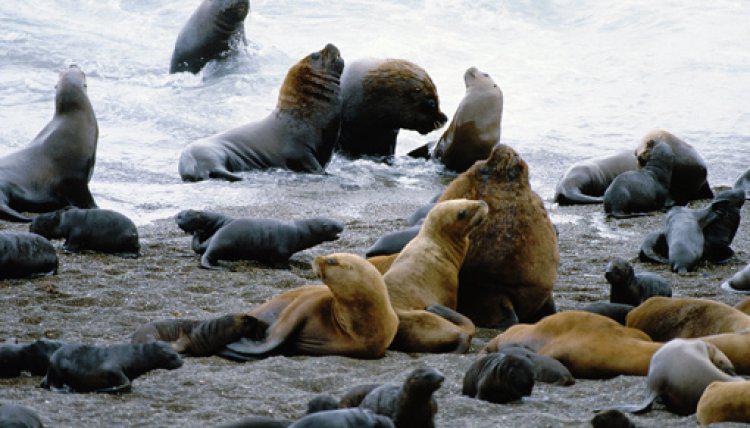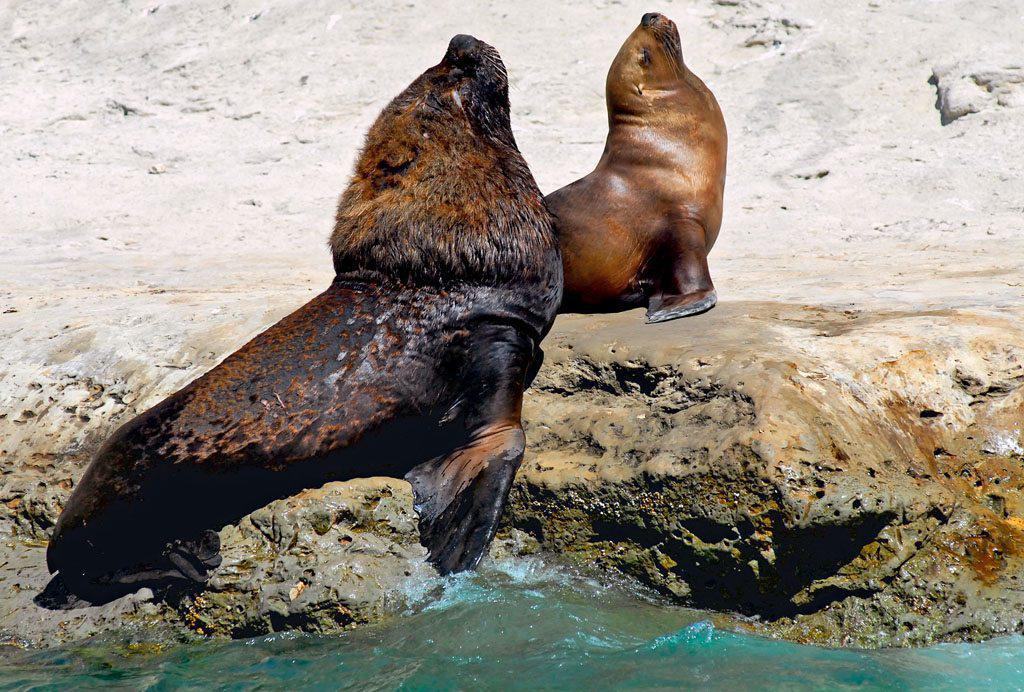The first image is the image on the left, the second image is the image on the right. Assess this claim about the two images: "The left image only has two seals.". Correct or not? Answer yes or no. No. The first image is the image on the left, the second image is the image on the right. Given the left and right images, does the statement "An image shows exactly two seals in direct contact, posed face to face." hold true? Answer yes or no. No. 